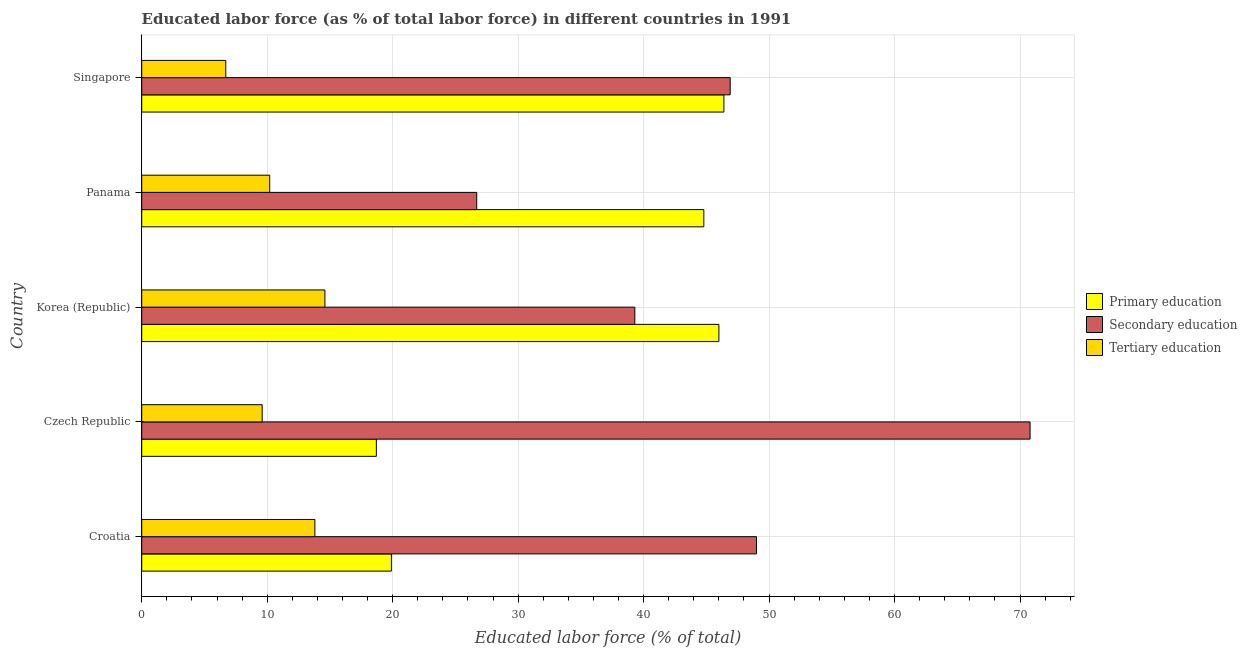How many different coloured bars are there?
Your answer should be compact. 3. How many groups of bars are there?
Keep it short and to the point. 5. Are the number of bars per tick equal to the number of legend labels?
Offer a terse response. Yes. Are the number of bars on each tick of the Y-axis equal?
Give a very brief answer. Yes. What is the label of the 5th group of bars from the top?
Offer a very short reply. Croatia. What is the percentage of labor force who received secondary education in Czech Republic?
Provide a short and direct response. 70.8. Across all countries, what is the maximum percentage of labor force who received tertiary education?
Your answer should be compact. 14.6. Across all countries, what is the minimum percentage of labor force who received primary education?
Make the answer very short. 18.7. In which country was the percentage of labor force who received primary education maximum?
Your answer should be compact. Singapore. In which country was the percentage of labor force who received primary education minimum?
Your response must be concise. Czech Republic. What is the total percentage of labor force who received tertiary education in the graph?
Ensure brevity in your answer.  54.9. What is the difference between the percentage of labor force who received tertiary education in Korea (Republic) and that in Panama?
Your answer should be very brief. 4.4. What is the difference between the percentage of labor force who received tertiary education in Czech Republic and the percentage of labor force who received secondary education in Croatia?
Give a very brief answer. -39.4. What is the average percentage of labor force who received primary education per country?
Provide a short and direct response. 35.16. What is the difference between the percentage of labor force who received secondary education and percentage of labor force who received tertiary education in Singapore?
Provide a succinct answer. 40.2. What is the ratio of the percentage of labor force who received tertiary education in Czech Republic to that in Singapore?
Offer a terse response. 1.43. Is the percentage of labor force who received primary education in Czech Republic less than that in Panama?
Ensure brevity in your answer.  Yes. Is the difference between the percentage of labor force who received secondary education in Croatia and Singapore greater than the difference between the percentage of labor force who received tertiary education in Croatia and Singapore?
Provide a succinct answer. No. What is the difference between the highest and the second highest percentage of labor force who received secondary education?
Your answer should be compact. 21.8. What is the difference between the highest and the lowest percentage of labor force who received primary education?
Offer a very short reply. 27.7. Is the sum of the percentage of labor force who received secondary education in Croatia and Korea (Republic) greater than the maximum percentage of labor force who received tertiary education across all countries?
Your answer should be very brief. Yes. What does the 3rd bar from the top in Panama represents?
Your response must be concise. Primary education. What does the 1st bar from the bottom in Panama represents?
Make the answer very short. Primary education. Is it the case that in every country, the sum of the percentage of labor force who received primary education and percentage of labor force who received secondary education is greater than the percentage of labor force who received tertiary education?
Make the answer very short. Yes. How many bars are there?
Make the answer very short. 15. How many countries are there in the graph?
Ensure brevity in your answer.  5. What is the difference between two consecutive major ticks on the X-axis?
Give a very brief answer. 10. Does the graph contain grids?
Offer a very short reply. Yes. How many legend labels are there?
Your answer should be compact. 3. What is the title of the graph?
Your answer should be compact. Educated labor force (as % of total labor force) in different countries in 1991. Does "Fuel" appear as one of the legend labels in the graph?
Provide a succinct answer. No. What is the label or title of the X-axis?
Give a very brief answer. Educated labor force (% of total). What is the label or title of the Y-axis?
Provide a short and direct response. Country. What is the Educated labor force (% of total) in Primary education in Croatia?
Your response must be concise. 19.9. What is the Educated labor force (% of total) in Secondary education in Croatia?
Offer a very short reply. 49. What is the Educated labor force (% of total) of Tertiary education in Croatia?
Your answer should be compact. 13.8. What is the Educated labor force (% of total) of Primary education in Czech Republic?
Offer a terse response. 18.7. What is the Educated labor force (% of total) of Secondary education in Czech Republic?
Offer a terse response. 70.8. What is the Educated labor force (% of total) in Tertiary education in Czech Republic?
Offer a very short reply. 9.6. What is the Educated labor force (% of total) of Secondary education in Korea (Republic)?
Make the answer very short. 39.3. What is the Educated labor force (% of total) in Tertiary education in Korea (Republic)?
Offer a very short reply. 14.6. What is the Educated labor force (% of total) of Primary education in Panama?
Provide a succinct answer. 44.8. What is the Educated labor force (% of total) in Secondary education in Panama?
Make the answer very short. 26.7. What is the Educated labor force (% of total) in Tertiary education in Panama?
Provide a short and direct response. 10.2. What is the Educated labor force (% of total) in Primary education in Singapore?
Offer a very short reply. 46.4. What is the Educated labor force (% of total) of Secondary education in Singapore?
Offer a very short reply. 46.9. What is the Educated labor force (% of total) in Tertiary education in Singapore?
Offer a very short reply. 6.7. Across all countries, what is the maximum Educated labor force (% of total) of Primary education?
Give a very brief answer. 46.4. Across all countries, what is the maximum Educated labor force (% of total) of Secondary education?
Make the answer very short. 70.8. Across all countries, what is the maximum Educated labor force (% of total) of Tertiary education?
Provide a short and direct response. 14.6. Across all countries, what is the minimum Educated labor force (% of total) in Primary education?
Provide a succinct answer. 18.7. Across all countries, what is the minimum Educated labor force (% of total) in Secondary education?
Give a very brief answer. 26.7. Across all countries, what is the minimum Educated labor force (% of total) in Tertiary education?
Make the answer very short. 6.7. What is the total Educated labor force (% of total) in Primary education in the graph?
Provide a short and direct response. 175.8. What is the total Educated labor force (% of total) of Secondary education in the graph?
Provide a short and direct response. 232.7. What is the total Educated labor force (% of total) of Tertiary education in the graph?
Offer a terse response. 54.9. What is the difference between the Educated labor force (% of total) in Secondary education in Croatia and that in Czech Republic?
Ensure brevity in your answer.  -21.8. What is the difference between the Educated labor force (% of total) of Primary education in Croatia and that in Korea (Republic)?
Your answer should be compact. -26.1. What is the difference between the Educated labor force (% of total) in Tertiary education in Croatia and that in Korea (Republic)?
Provide a succinct answer. -0.8. What is the difference between the Educated labor force (% of total) of Primary education in Croatia and that in Panama?
Offer a very short reply. -24.9. What is the difference between the Educated labor force (% of total) of Secondary education in Croatia and that in Panama?
Ensure brevity in your answer.  22.3. What is the difference between the Educated labor force (% of total) of Primary education in Croatia and that in Singapore?
Your answer should be very brief. -26.5. What is the difference between the Educated labor force (% of total) of Secondary education in Croatia and that in Singapore?
Make the answer very short. 2.1. What is the difference between the Educated labor force (% of total) in Tertiary education in Croatia and that in Singapore?
Your answer should be very brief. 7.1. What is the difference between the Educated labor force (% of total) of Primary education in Czech Republic and that in Korea (Republic)?
Your answer should be compact. -27.3. What is the difference between the Educated labor force (% of total) in Secondary education in Czech Republic and that in Korea (Republic)?
Provide a succinct answer. 31.5. What is the difference between the Educated labor force (% of total) of Tertiary education in Czech Republic and that in Korea (Republic)?
Your response must be concise. -5. What is the difference between the Educated labor force (% of total) of Primary education in Czech Republic and that in Panama?
Offer a very short reply. -26.1. What is the difference between the Educated labor force (% of total) of Secondary education in Czech Republic and that in Panama?
Offer a very short reply. 44.1. What is the difference between the Educated labor force (% of total) in Primary education in Czech Republic and that in Singapore?
Make the answer very short. -27.7. What is the difference between the Educated labor force (% of total) in Secondary education in Czech Republic and that in Singapore?
Ensure brevity in your answer.  23.9. What is the difference between the Educated labor force (% of total) of Secondary education in Korea (Republic) and that in Panama?
Your answer should be very brief. 12.6. What is the difference between the Educated labor force (% of total) of Secondary education in Korea (Republic) and that in Singapore?
Keep it short and to the point. -7.6. What is the difference between the Educated labor force (% of total) of Secondary education in Panama and that in Singapore?
Make the answer very short. -20.2. What is the difference between the Educated labor force (% of total) in Primary education in Croatia and the Educated labor force (% of total) in Secondary education in Czech Republic?
Your answer should be compact. -50.9. What is the difference between the Educated labor force (% of total) of Primary education in Croatia and the Educated labor force (% of total) of Tertiary education in Czech Republic?
Make the answer very short. 10.3. What is the difference between the Educated labor force (% of total) of Secondary education in Croatia and the Educated labor force (% of total) of Tertiary education in Czech Republic?
Provide a short and direct response. 39.4. What is the difference between the Educated labor force (% of total) of Primary education in Croatia and the Educated labor force (% of total) of Secondary education in Korea (Republic)?
Offer a very short reply. -19.4. What is the difference between the Educated labor force (% of total) of Secondary education in Croatia and the Educated labor force (% of total) of Tertiary education in Korea (Republic)?
Give a very brief answer. 34.4. What is the difference between the Educated labor force (% of total) of Primary education in Croatia and the Educated labor force (% of total) of Secondary education in Panama?
Provide a succinct answer. -6.8. What is the difference between the Educated labor force (% of total) in Primary education in Croatia and the Educated labor force (% of total) in Tertiary education in Panama?
Keep it short and to the point. 9.7. What is the difference between the Educated labor force (% of total) in Secondary education in Croatia and the Educated labor force (% of total) in Tertiary education in Panama?
Offer a very short reply. 38.8. What is the difference between the Educated labor force (% of total) of Secondary education in Croatia and the Educated labor force (% of total) of Tertiary education in Singapore?
Your answer should be compact. 42.3. What is the difference between the Educated labor force (% of total) of Primary education in Czech Republic and the Educated labor force (% of total) of Secondary education in Korea (Republic)?
Keep it short and to the point. -20.6. What is the difference between the Educated labor force (% of total) of Secondary education in Czech Republic and the Educated labor force (% of total) of Tertiary education in Korea (Republic)?
Your response must be concise. 56.2. What is the difference between the Educated labor force (% of total) in Primary education in Czech Republic and the Educated labor force (% of total) in Secondary education in Panama?
Make the answer very short. -8. What is the difference between the Educated labor force (% of total) of Secondary education in Czech Republic and the Educated labor force (% of total) of Tertiary education in Panama?
Your answer should be very brief. 60.6. What is the difference between the Educated labor force (% of total) of Primary education in Czech Republic and the Educated labor force (% of total) of Secondary education in Singapore?
Provide a succinct answer. -28.2. What is the difference between the Educated labor force (% of total) in Secondary education in Czech Republic and the Educated labor force (% of total) in Tertiary education in Singapore?
Keep it short and to the point. 64.1. What is the difference between the Educated labor force (% of total) in Primary education in Korea (Republic) and the Educated labor force (% of total) in Secondary education in Panama?
Give a very brief answer. 19.3. What is the difference between the Educated labor force (% of total) of Primary education in Korea (Republic) and the Educated labor force (% of total) of Tertiary education in Panama?
Keep it short and to the point. 35.8. What is the difference between the Educated labor force (% of total) in Secondary education in Korea (Republic) and the Educated labor force (% of total) in Tertiary education in Panama?
Make the answer very short. 29.1. What is the difference between the Educated labor force (% of total) of Primary education in Korea (Republic) and the Educated labor force (% of total) of Tertiary education in Singapore?
Your answer should be compact. 39.3. What is the difference between the Educated labor force (% of total) of Secondary education in Korea (Republic) and the Educated labor force (% of total) of Tertiary education in Singapore?
Give a very brief answer. 32.6. What is the difference between the Educated labor force (% of total) in Primary education in Panama and the Educated labor force (% of total) in Secondary education in Singapore?
Provide a short and direct response. -2.1. What is the difference between the Educated labor force (% of total) in Primary education in Panama and the Educated labor force (% of total) in Tertiary education in Singapore?
Your response must be concise. 38.1. What is the average Educated labor force (% of total) of Primary education per country?
Your answer should be very brief. 35.16. What is the average Educated labor force (% of total) in Secondary education per country?
Your answer should be compact. 46.54. What is the average Educated labor force (% of total) of Tertiary education per country?
Give a very brief answer. 10.98. What is the difference between the Educated labor force (% of total) in Primary education and Educated labor force (% of total) in Secondary education in Croatia?
Your response must be concise. -29.1. What is the difference between the Educated labor force (% of total) in Primary education and Educated labor force (% of total) in Tertiary education in Croatia?
Provide a short and direct response. 6.1. What is the difference between the Educated labor force (% of total) of Secondary education and Educated labor force (% of total) of Tertiary education in Croatia?
Keep it short and to the point. 35.2. What is the difference between the Educated labor force (% of total) of Primary education and Educated labor force (% of total) of Secondary education in Czech Republic?
Keep it short and to the point. -52.1. What is the difference between the Educated labor force (% of total) of Primary education and Educated labor force (% of total) of Tertiary education in Czech Republic?
Provide a short and direct response. 9.1. What is the difference between the Educated labor force (% of total) of Secondary education and Educated labor force (% of total) of Tertiary education in Czech Republic?
Provide a short and direct response. 61.2. What is the difference between the Educated labor force (% of total) of Primary education and Educated labor force (% of total) of Secondary education in Korea (Republic)?
Your answer should be very brief. 6.7. What is the difference between the Educated labor force (% of total) of Primary education and Educated labor force (% of total) of Tertiary education in Korea (Republic)?
Your answer should be very brief. 31.4. What is the difference between the Educated labor force (% of total) of Secondary education and Educated labor force (% of total) of Tertiary education in Korea (Republic)?
Provide a succinct answer. 24.7. What is the difference between the Educated labor force (% of total) of Primary education and Educated labor force (% of total) of Secondary education in Panama?
Your answer should be compact. 18.1. What is the difference between the Educated labor force (% of total) of Primary education and Educated labor force (% of total) of Tertiary education in Panama?
Your answer should be very brief. 34.6. What is the difference between the Educated labor force (% of total) of Primary education and Educated labor force (% of total) of Tertiary education in Singapore?
Offer a very short reply. 39.7. What is the difference between the Educated labor force (% of total) in Secondary education and Educated labor force (% of total) in Tertiary education in Singapore?
Provide a short and direct response. 40.2. What is the ratio of the Educated labor force (% of total) of Primary education in Croatia to that in Czech Republic?
Give a very brief answer. 1.06. What is the ratio of the Educated labor force (% of total) of Secondary education in Croatia to that in Czech Republic?
Your answer should be very brief. 0.69. What is the ratio of the Educated labor force (% of total) in Tertiary education in Croatia to that in Czech Republic?
Your response must be concise. 1.44. What is the ratio of the Educated labor force (% of total) in Primary education in Croatia to that in Korea (Republic)?
Keep it short and to the point. 0.43. What is the ratio of the Educated labor force (% of total) in Secondary education in Croatia to that in Korea (Republic)?
Keep it short and to the point. 1.25. What is the ratio of the Educated labor force (% of total) of Tertiary education in Croatia to that in Korea (Republic)?
Provide a short and direct response. 0.95. What is the ratio of the Educated labor force (% of total) of Primary education in Croatia to that in Panama?
Provide a succinct answer. 0.44. What is the ratio of the Educated labor force (% of total) in Secondary education in Croatia to that in Panama?
Your answer should be very brief. 1.84. What is the ratio of the Educated labor force (% of total) in Tertiary education in Croatia to that in Panama?
Give a very brief answer. 1.35. What is the ratio of the Educated labor force (% of total) in Primary education in Croatia to that in Singapore?
Your response must be concise. 0.43. What is the ratio of the Educated labor force (% of total) of Secondary education in Croatia to that in Singapore?
Give a very brief answer. 1.04. What is the ratio of the Educated labor force (% of total) in Tertiary education in Croatia to that in Singapore?
Make the answer very short. 2.06. What is the ratio of the Educated labor force (% of total) in Primary education in Czech Republic to that in Korea (Republic)?
Your response must be concise. 0.41. What is the ratio of the Educated labor force (% of total) in Secondary education in Czech Republic to that in Korea (Republic)?
Provide a short and direct response. 1.8. What is the ratio of the Educated labor force (% of total) in Tertiary education in Czech Republic to that in Korea (Republic)?
Offer a terse response. 0.66. What is the ratio of the Educated labor force (% of total) in Primary education in Czech Republic to that in Panama?
Provide a succinct answer. 0.42. What is the ratio of the Educated labor force (% of total) of Secondary education in Czech Republic to that in Panama?
Keep it short and to the point. 2.65. What is the ratio of the Educated labor force (% of total) in Primary education in Czech Republic to that in Singapore?
Offer a terse response. 0.4. What is the ratio of the Educated labor force (% of total) in Secondary education in Czech Republic to that in Singapore?
Your answer should be compact. 1.51. What is the ratio of the Educated labor force (% of total) of Tertiary education in Czech Republic to that in Singapore?
Your response must be concise. 1.43. What is the ratio of the Educated labor force (% of total) in Primary education in Korea (Republic) to that in Panama?
Your response must be concise. 1.03. What is the ratio of the Educated labor force (% of total) in Secondary education in Korea (Republic) to that in Panama?
Offer a terse response. 1.47. What is the ratio of the Educated labor force (% of total) in Tertiary education in Korea (Republic) to that in Panama?
Make the answer very short. 1.43. What is the ratio of the Educated labor force (% of total) of Primary education in Korea (Republic) to that in Singapore?
Keep it short and to the point. 0.99. What is the ratio of the Educated labor force (% of total) in Secondary education in Korea (Republic) to that in Singapore?
Offer a very short reply. 0.84. What is the ratio of the Educated labor force (% of total) in Tertiary education in Korea (Republic) to that in Singapore?
Provide a short and direct response. 2.18. What is the ratio of the Educated labor force (% of total) of Primary education in Panama to that in Singapore?
Your response must be concise. 0.97. What is the ratio of the Educated labor force (% of total) of Secondary education in Panama to that in Singapore?
Ensure brevity in your answer.  0.57. What is the ratio of the Educated labor force (% of total) in Tertiary education in Panama to that in Singapore?
Offer a very short reply. 1.52. What is the difference between the highest and the second highest Educated labor force (% of total) of Secondary education?
Your response must be concise. 21.8. What is the difference between the highest and the second highest Educated labor force (% of total) of Tertiary education?
Give a very brief answer. 0.8. What is the difference between the highest and the lowest Educated labor force (% of total) of Primary education?
Offer a terse response. 27.7. What is the difference between the highest and the lowest Educated labor force (% of total) of Secondary education?
Give a very brief answer. 44.1. 